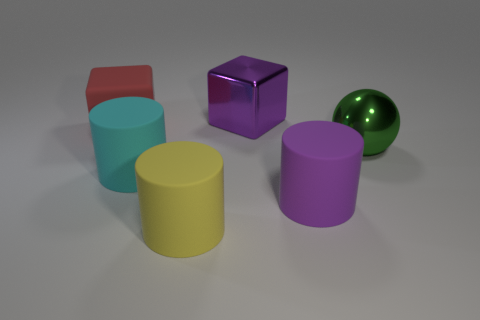What number of large things are there?
Provide a succinct answer. 6. Is the big yellow cylinder made of the same material as the purple object that is behind the large cyan matte cylinder?
Provide a succinct answer. No. Does the big shiny object left of the green sphere have the same color as the large shiny sphere?
Offer a terse response. No. There is a large thing that is behind the large cyan cylinder and to the right of the large metallic cube; what material is it made of?
Keep it short and to the point. Metal. What size is the yellow rubber cylinder?
Provide a succinct answer. Large. There is a large matte block; does it have the same color as the large shiny object behind the red rubber block?
Your answer should be very brief. No. How many other things are there of the same color as the big metal block?
Keep it short and to the point. 1. Does the purple thing that is behind the purple cylinder have the same size as the yellow cylinder in front of the big red rubber block?
Give a very brief answer. Yes. What is the color of the shiny thing behind the large red rubber object?
Offer a terse response. Purple. Are there fewer purple things that are behind the shiny block than big gray cylinders?
Provide a succinct answer. No. 